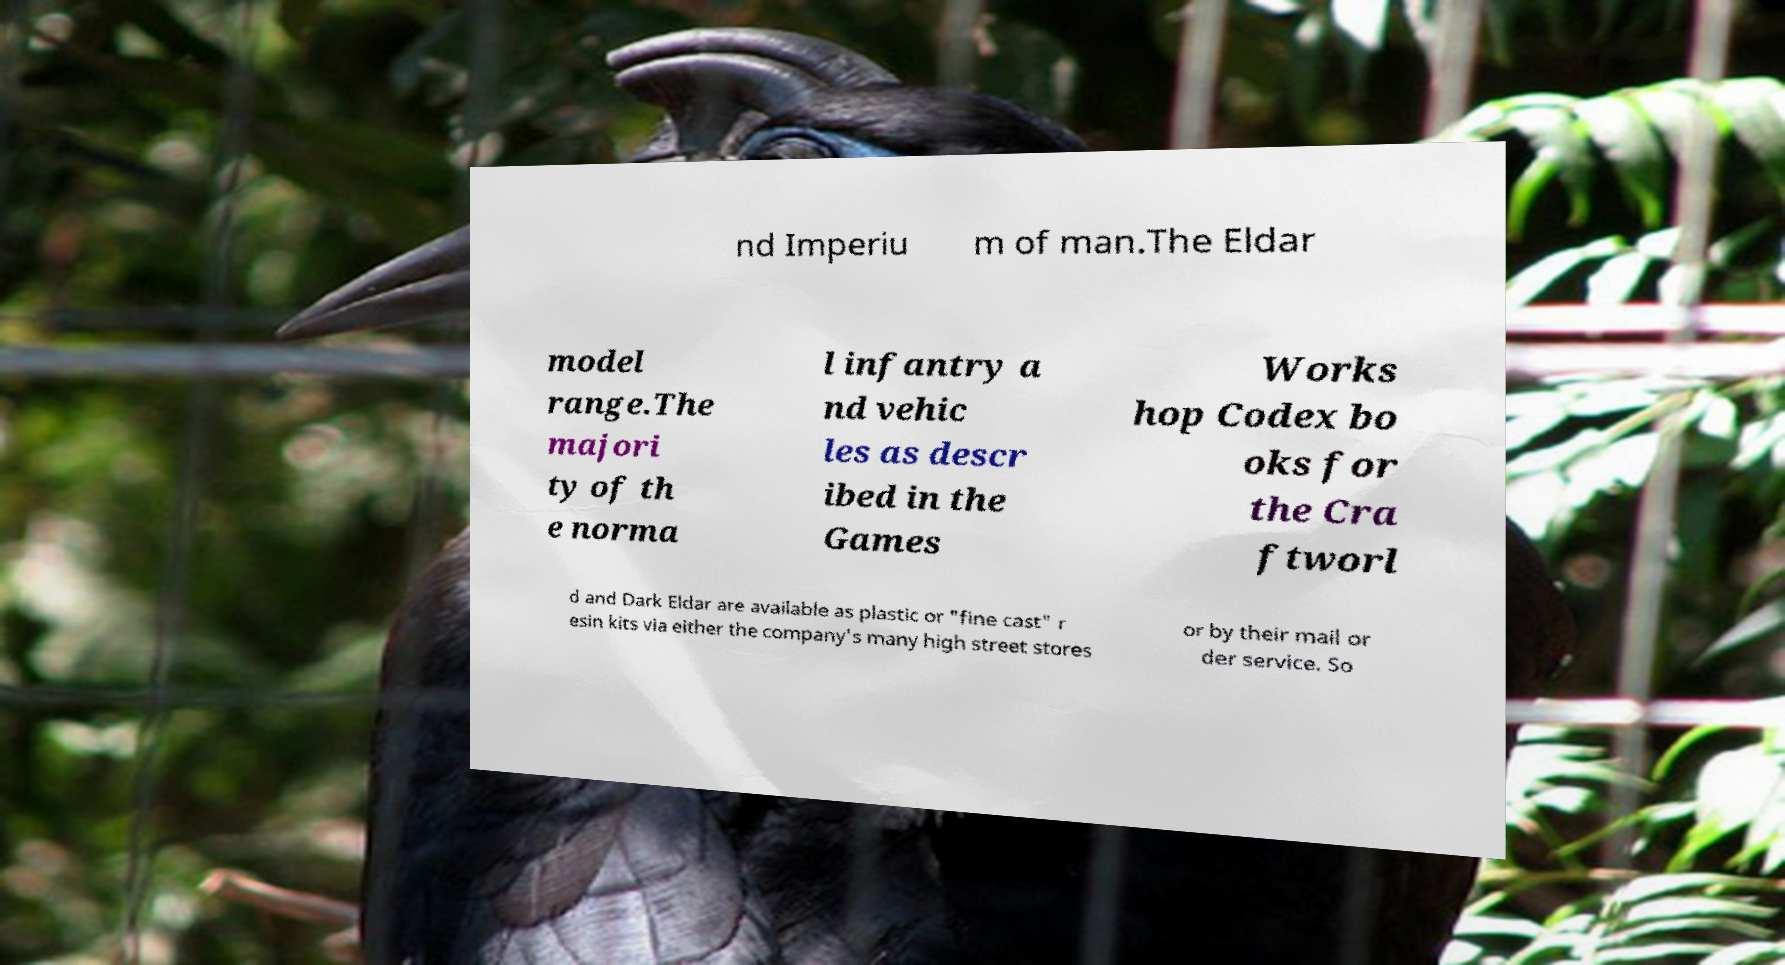Please read and relay the text visible in this image. What does it say? nd Imperiu m of man.The Eldar model range.The majori ty of th e norma l infantry a nd vehic les as descr ibed in the Games Works hop Codex bo oks for the Cra ftworl d and Dark Eldar are available as plastic or "fine cast" r esin kits via either the company's many high street stores or by their mail or der service. So 